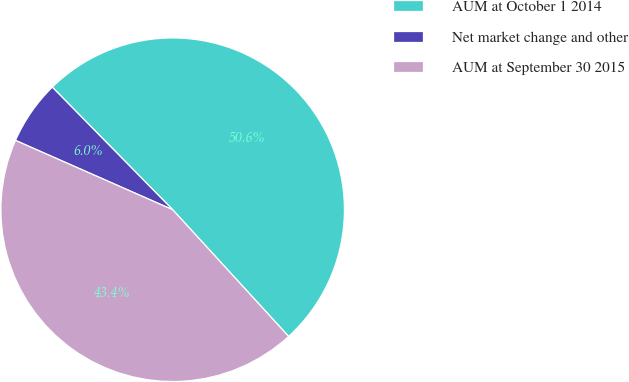Convert chart to OTSL. <chart><loc_0><loc_0><loc_500><loc_500><pie_chart><fcel>AUM at October 1 2014<fcel>Net market change and other<fcel>AUM at September 30 2015<nl><fcel>50.56%<fcel>6.03%<fcel>43.41%<nl></chart> 